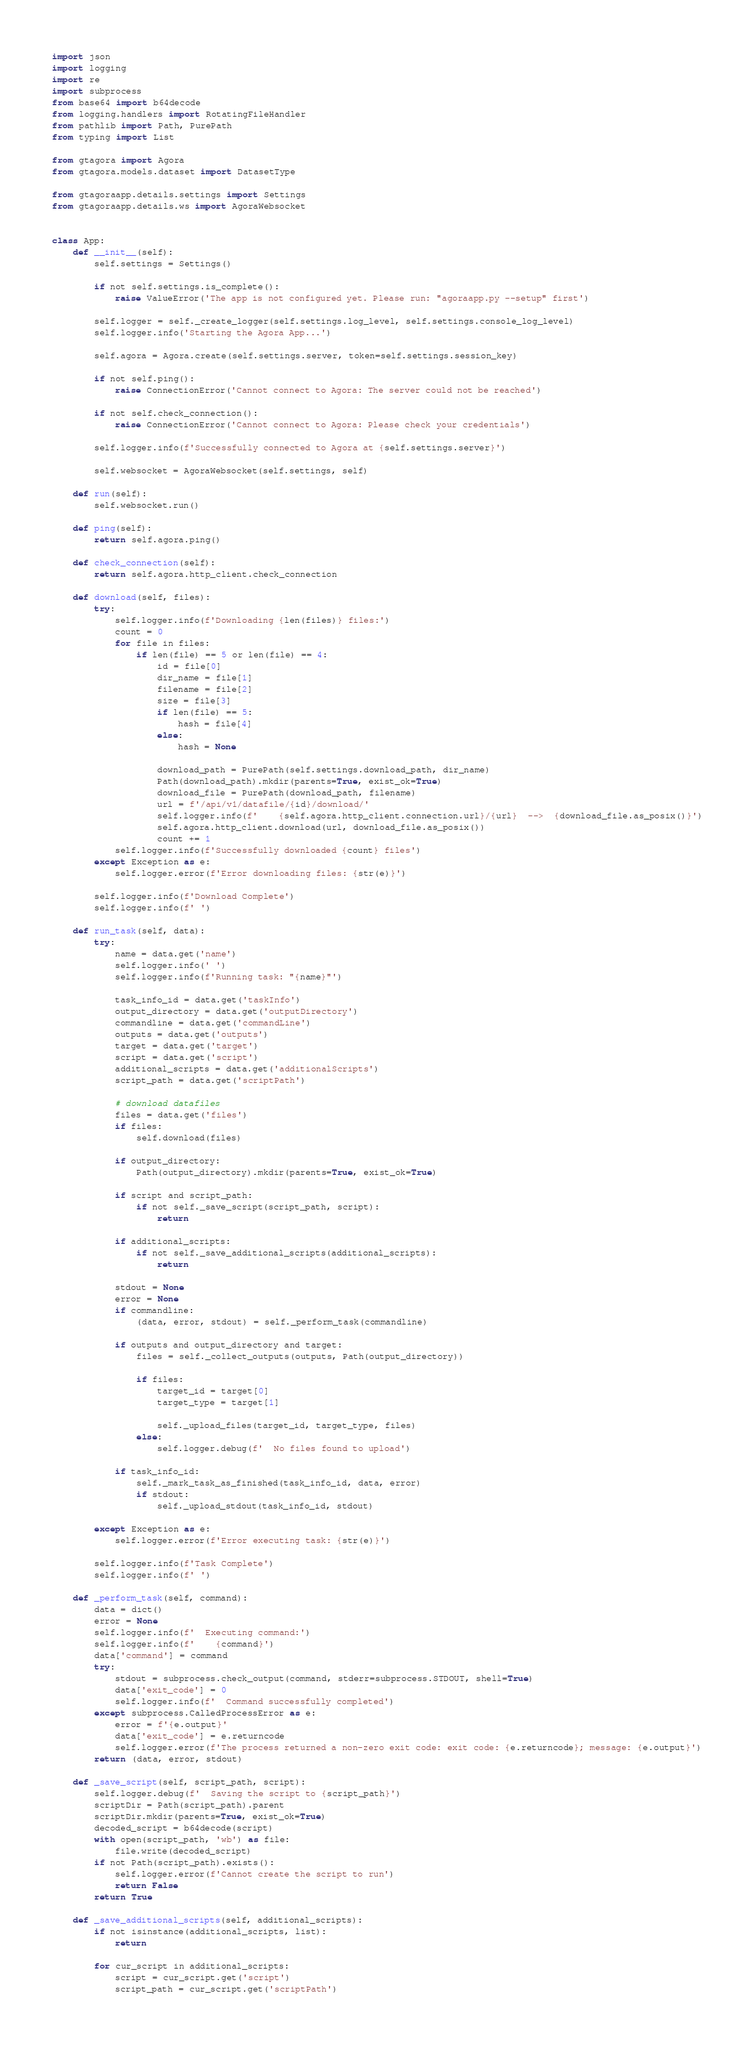<code> <loc_0><loc_0><loc_500><loc_500><_Python_>import json
import logging
import re
import subprocess
from base64 import b64decode
from logging.handlers import RotatingFileHandler
from pathlib import Path, PurePath
from typing import List

from gtagora import Agora
from gtagora.models.dataset import DatasetType

from gtagoraapp.details.settings import Settings
from gtagoraapp.details.ws import AgoraWebsocket


class App:
    def __init__(self):
        self.settings = Settings()

        if not self.settings.is_complete():
            raise ValueError('The app is not configured yet. Please run: "agoraapp.py --setup" first')

        self.logger = self._create_logger(self.settings.log_level, self.settings.console_log_level)
        self.logger.info('Starting the Agora App...')

        self.agora = Agora.create(self.settings.server, token=self.settings.session_key)

        if not self.ping():
            raise ConnectionError('Cannot connect to Agora: The server could not be reached')

        if not self.check_connection():
            raise ConnectionError('Cannot connect to Agora: Please check your credentials')

        self.logger.info(f'Successfully connected to Agora at {self.settings.server}')

        self.websocket = AgoraWebsocket(self.settings, self)

    def run(self):
        self.websocket.run()

    def ping(self):
        return self.agora.ping()

    def check_connection(self):
        return self.agora.http_client.check_connection

    def download(self, files):
        try:
            self.logger.info(f'Downloading {len(files)} files:')
            count = 0
            for file in files:
                if len(file) == 5 or len(file) == 4:
                    id = file[0]
                    dir_name = file[1]
                    filename = file[2]
                    size = file[3]
                    if len(file) == 5:
                        hash = file[4]
                    else:
                        hash = None

                    download_path = PurePath(self.settings.download_path, dir_name)
                    Path(download_path).mkdir(parents=True, exist_ok=True)
                    download_file = PurePath(download_path, filename)
                    url = f'/api/v1/datafile/{id}/download/'
                    self.logger.info(f'    {self.agora.http_client.connection.url}/{url}  -->  {download_file.as_posix()}')
                    self.agora.http_client.download(url, download_file.as_posix())
                    count += 1
            self.logger.info(f'Successfully downloaded {count} files')
        except Exception as e:
            self.logger.error(f'Error downloading files: {str(e)}')

        self.logger.info(f'Download Complete')
        self.logger.info(f' ')

    def run_task(self, data):
        try:
            name = data.get('name')
            self.logger.info(' ')
            self.logger.info(f'Running task: "{name}"')

            task_info_id = data.get('taskInfo')
            output_directory = data.get('outputDirectory')
            commandline = data.get('commandLine')
            outputs = data.get('outputs')
            target = data.get('target')
            script = data.get('script')
            additional_scripts = data.get('additionalScripts')
            script_path = data.get('scriptPath')

            # download datafiles
            files = data.get('files')
            if files:
                self.download(files)

            if output_directory:
                Path(output_directory).mkdir(parents=True, exist_ok=True)

            if script and script_path:
                if not self._save_script(script_path, script):
                    return

            if additional_scripts:
                if not self._save_additional_scripts(additional_scripts):
                    return

            stdout = None
            error = None
            if commandline:
                (data, error, stdout) = self._perform_task(commandline)

            if outputs and output_directory and target:
                files = self._collect_outputs(outputs, Path(output_directory))

                if files:
                    target_id = target[0]
                    target_type = target[1]

                    self._upload_files(target_id, target_type, files)
                else:
                    self.logger.debug(f'  No files found to upload')

            if task_info_id:
                self._mark_task_as_finished(task_info_id, data, error)
                if stdout:
                    self._upload_stdout(task_info_id, stdout)

        except Exception as e:
            self.logger.error(f'Error executing task: {str(e)}')

        self.logger.info(f'Task Complete')
        self.logger.info(f' ')

    def _perform_task(self, command):
        data = dict()
        error = None
        self.logger.info(f'  Executing command:')
        self.logger.info(f'    {command}')
        data['command'] = command
        try:
            stdout = subprocess.check_output(command, stderr=subprocess.STDOUT, shell=True)
            data['exit_code'] = 0
            self.logger.info(f'  Command successfully completed')
        except subprocess.CalledProcessError as e:
            error = f'{e.output}'
            data['exit_code'] = e.returncode
            self.logger.error(f'The process returned a non-zero exit code: exit code: {e.returncode}; message: {e.output}')
        return (data, error, stdout)

    def _save_script(self, script_path, script):
        self.logger.debug(f'  Saving the script to {script_path}')
        scriptDir = Path(script_path).parent
        scriptDir.mkdir(parents=True, exist_ok=True)
        decoded_script = b64decode(script)
        with open(script_path, 'wb') as file:
            file.write(decoded_script)
        if not Path(script_path).exists():
            self.logger.error(f'Cannot create the script to run')
            return False
        return True

    def _save_additional_scripts(self, additional_scripts):
        if not isinstance(additional_scripts, list):
            return

        for cur_script in additional_scripts:
            script = cur_script.get('script')
            script_path = cur_script.get('scriptPath')</code> 